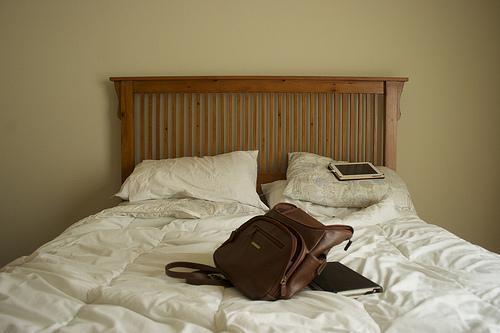How many tablets are shown?
Give a very brief answer. 1. How many pillows are shown?
Give a very brief answer. 3. 